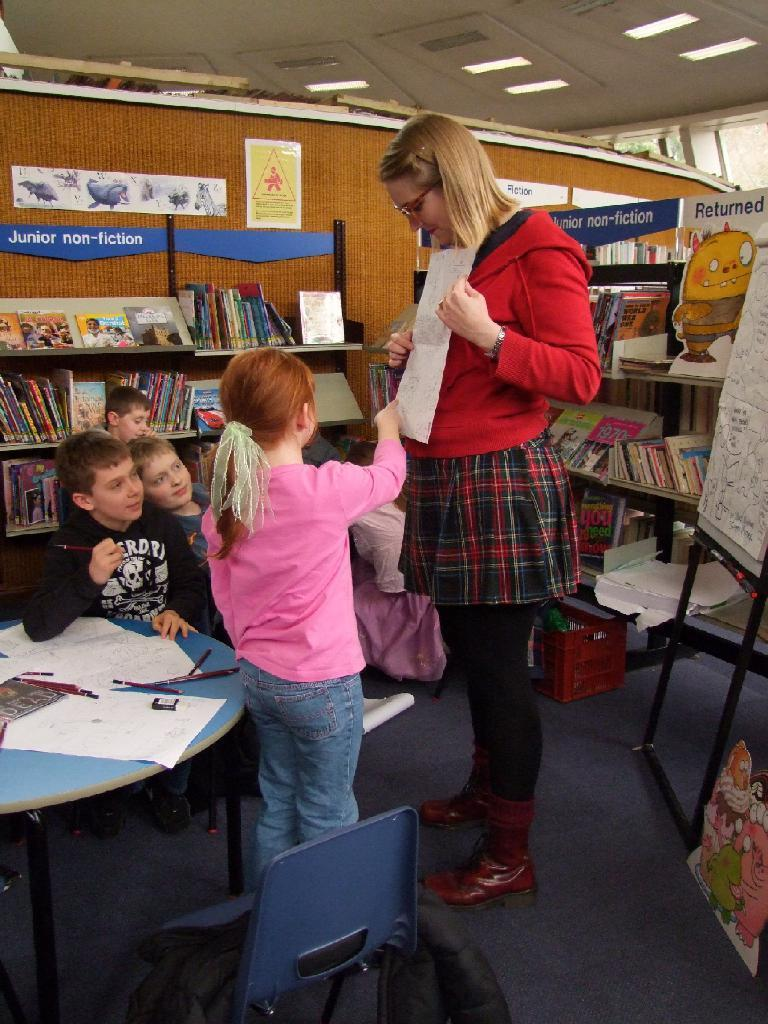Who are the people standing in the image? There is a child and a lady standing in the image. What are the children near the table doing? There are children sitting near a table in the image. What can be seen on the shelf in the background? There are books on a shelf in the background of the image. What else is visible in the background of the image? There is a wall and a board visible in the background of the image. Can you tell me how many oranges are on the table in the image? There are no oranges present in the image. What type of duck can be seen interacting with the children in the image? There is no duck present in the image; only the child, lady, and other children are visible. 